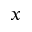<formula> <loc_0><loc_0><loc_500><loc_500>x</formula> 